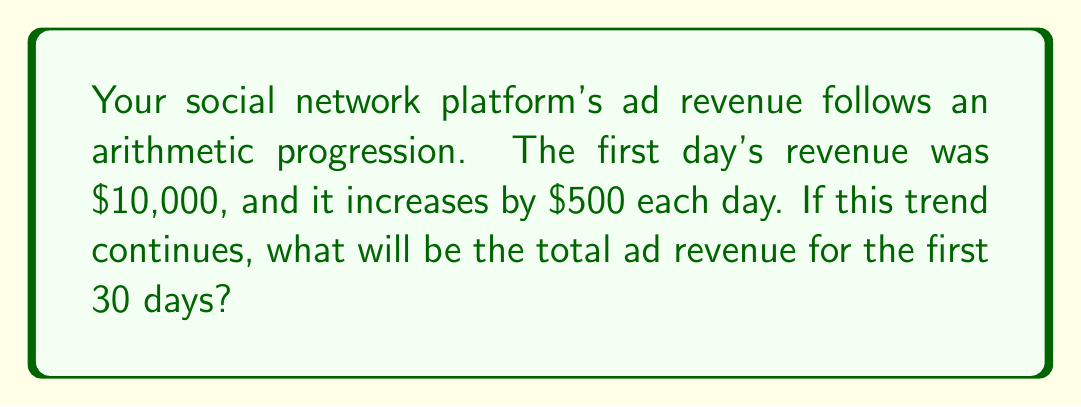Can you solve this math problem? Let's approach this step-by-step using the arithmetic progression formula:

1) In an arithmetic progression, we have:
   $a_1$ = first term
   $d$ = common difference
   $n$ = number of terms
   $S_n$ = sum of $n$ terms

2) We're given:
   $a_1 = 10000$ (first day's revenue)
   $d = 500$ (daily increase)
   $n = 30$ (total days)

3) The formula for the sum of an arithmetic progression is:
   $$S_n = \frac{n}{2}(a_1 + a_n)$$
   where $a_n$ is the last term

4) To find $a_n$, we use the formula:
   $$a_n = a_1 + (n-1)d$$
   $$a_{30} = 10000 + (30-1)500 = 10000 + 14500 = 24500$$

5) Now we can calculate the sum:
   $$S_{30} = \frac{30}{2}(10000 + 24500)$$
   $$S_{30} = 15(34500) = 517500$$

Therefore, the total ad revenue for the first 30 days will be $517,500.
Answer: $517,500 